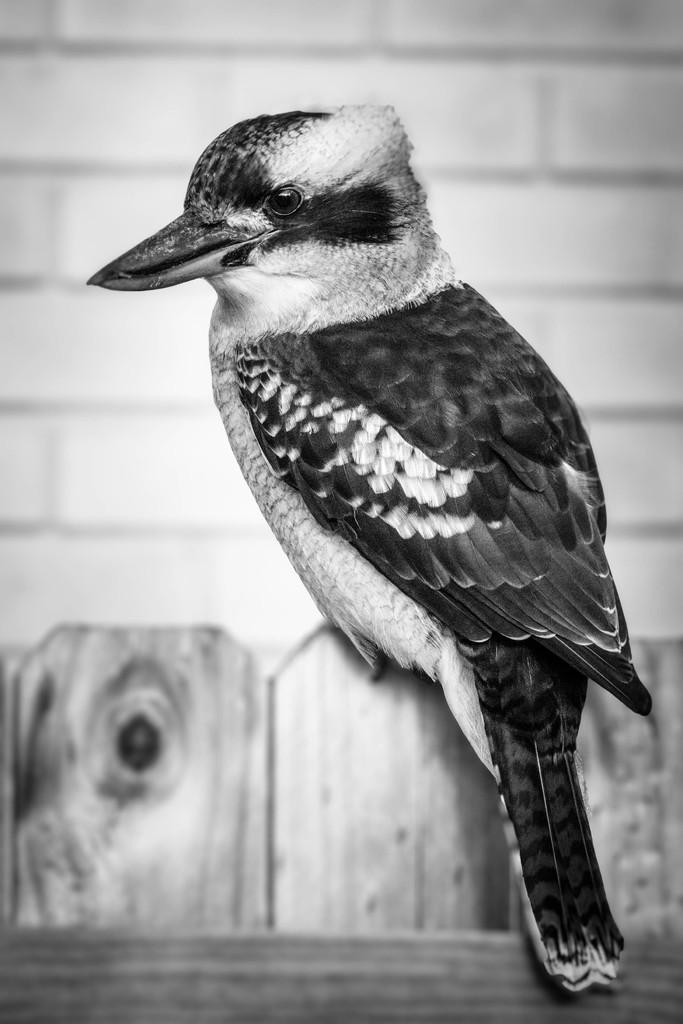What type of animal can be seen in the image? There is a bird in the image. Where is the bird located? The bird is sitting on a wooden object. What can be seen in the background of the image? There is a wall in the image. What type of adjustment is the bird making to its trousers in the image? There are no trousers present in the image, and the bird is not making any adjustments. 